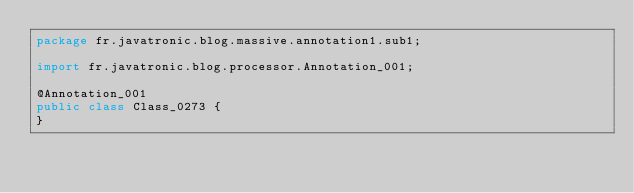<code> <loc_0><loc_0><loc_500><loc_500><_Java_>package fr.javatronic.blog.massive.annotation1.sub1;

import fr.javatronic.blog.processor.Annotation_001;

@Annotation_001
public class Class_0273 {
}
</code> 